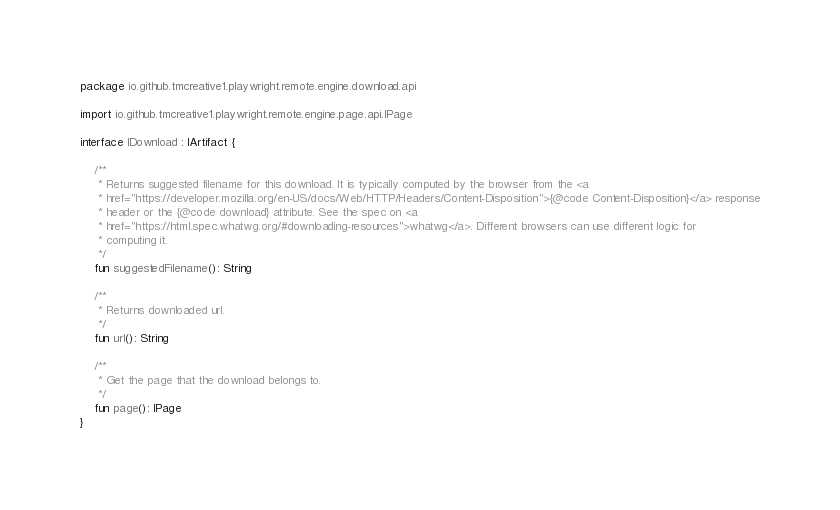<code> <loc_0><loc_0><loc_500><loc_500><_Kotlin_>package io.github.tmcreative1.playwright.remote.engine.download.api

import io.github.tmcreative1.playwright.remote.engine.page.api.IPage

interface IDownload : IArtifact {

    /**
     * Returns suggested filename for this download. It is typically computed by the browser from the <a
     * href="https://developer.mozilla.org/en-US/docs/Web/HTTP/Headers/Content-Disposition">{@code Content-Disposition}</a> response
     * header or the {@code download} attribute. See the spec on <a
     * href="https://html.spec.whatwg.org/#downloading-resources">whatwg</a>. Different browsers can use different logic for
     * computing it.
     */
    fun suggestedFilename(): String

    /**
     * Returns downloaded url.
     */
    fun url(): String

    /**
     * Get the page that the download belongs to.
     */
    fun page(): IPage
}</code> 